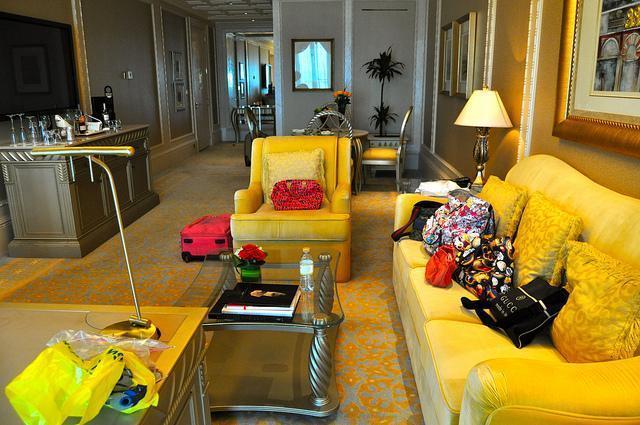How many books are in the picture?
Give a very brief answer. 1. How many backpacks are there?
Give a very brief answer. 2. 